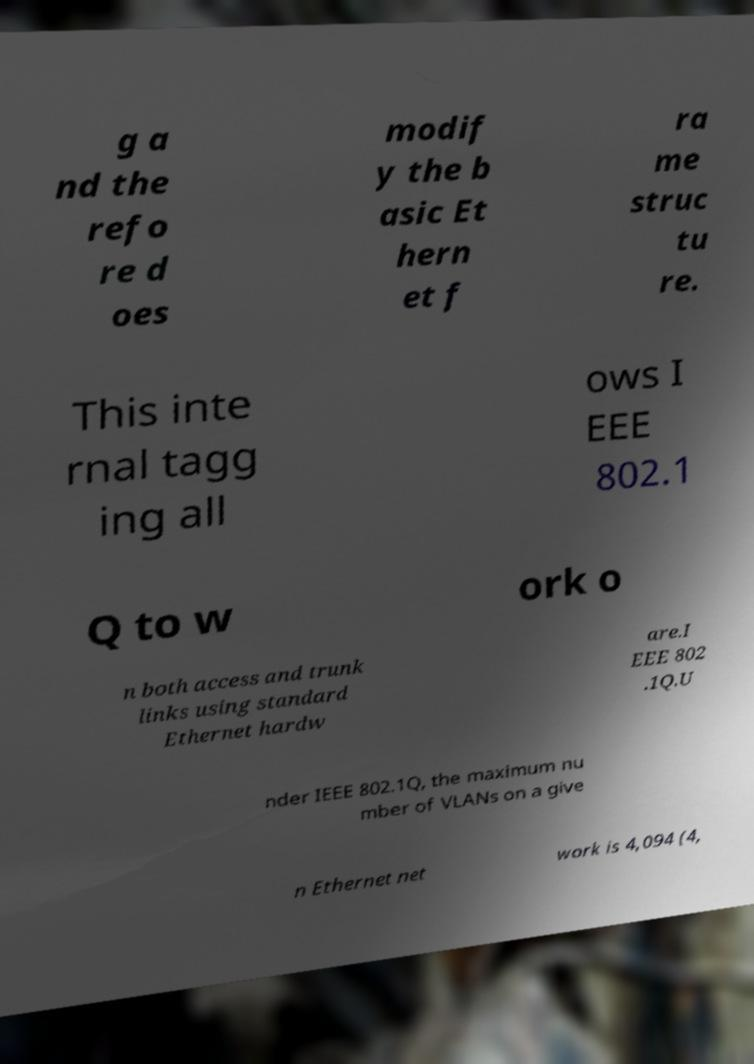There's text embedded in this image that I need extracted. Can you transcribe it verbatim? g a nd the refo re d oes modif y the b asic Et hern et f ra me struc tu re. This inte rnal tagg ing all ows I EEE 802.1 Q to w ork o n both access and trunk links using standard Ethernet hardw are.I EEE 802 .1Q.U nder IEEE 802.1Q, the maximum nu mber of VLANs on a give n Ethernet net work is 4,094 (4, 